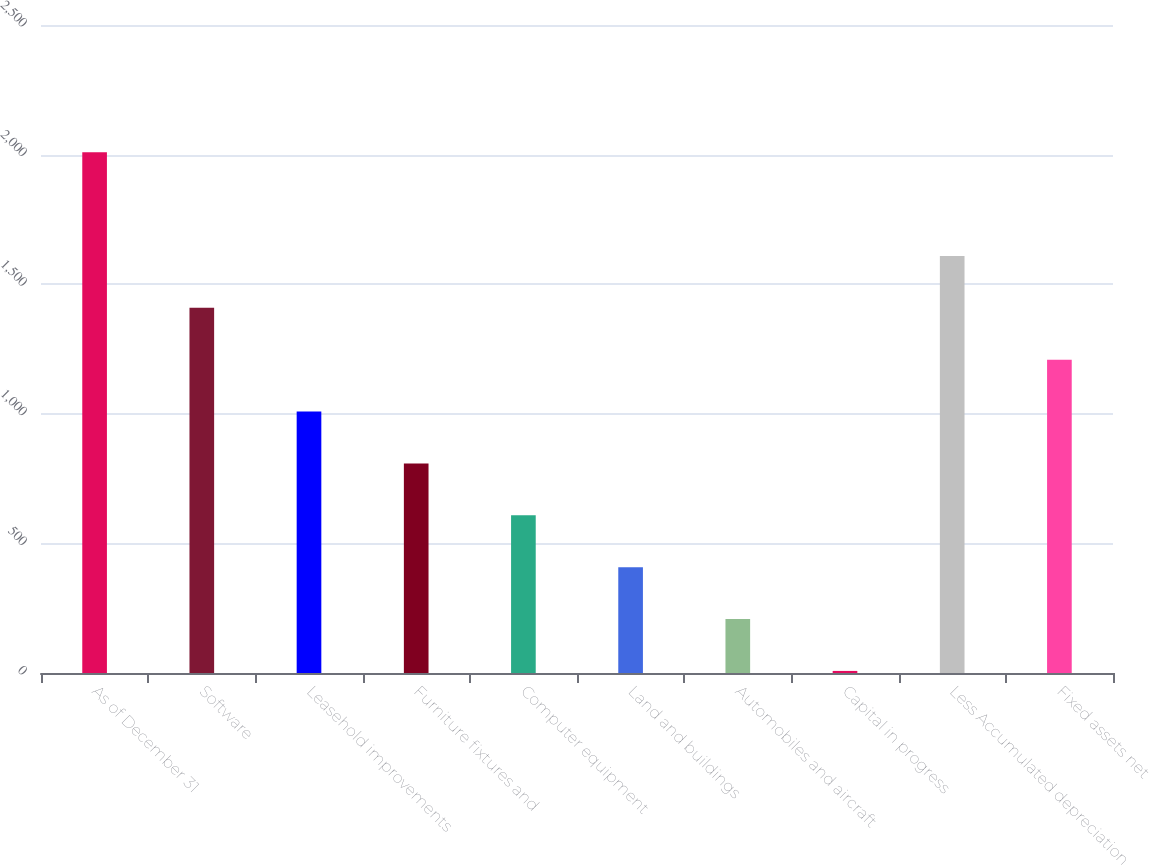Convert chart. <chart><loc_0><loc_0><loc_500><loc_500><bar_chart><fcel>As of December 31<fcel>Software<fcel>Leasehold improvements<fcel>Furniture fixtures and<fcel>Computer equipment<fcel>Land and buildings<fcel>Automobiles and aircraft<fcel>Capital in progress<fcel>Less Accumulated depreciation<fcel>Fixed assets net<nl><fcel>2009<fcel>1408.7<fcel>1008.5<fcel>808.4<fcel>608.3<fcel>408.2<fcel>208.1<fcel>8<fcel>1608.8<fcel>1208.6<nl></chart> 